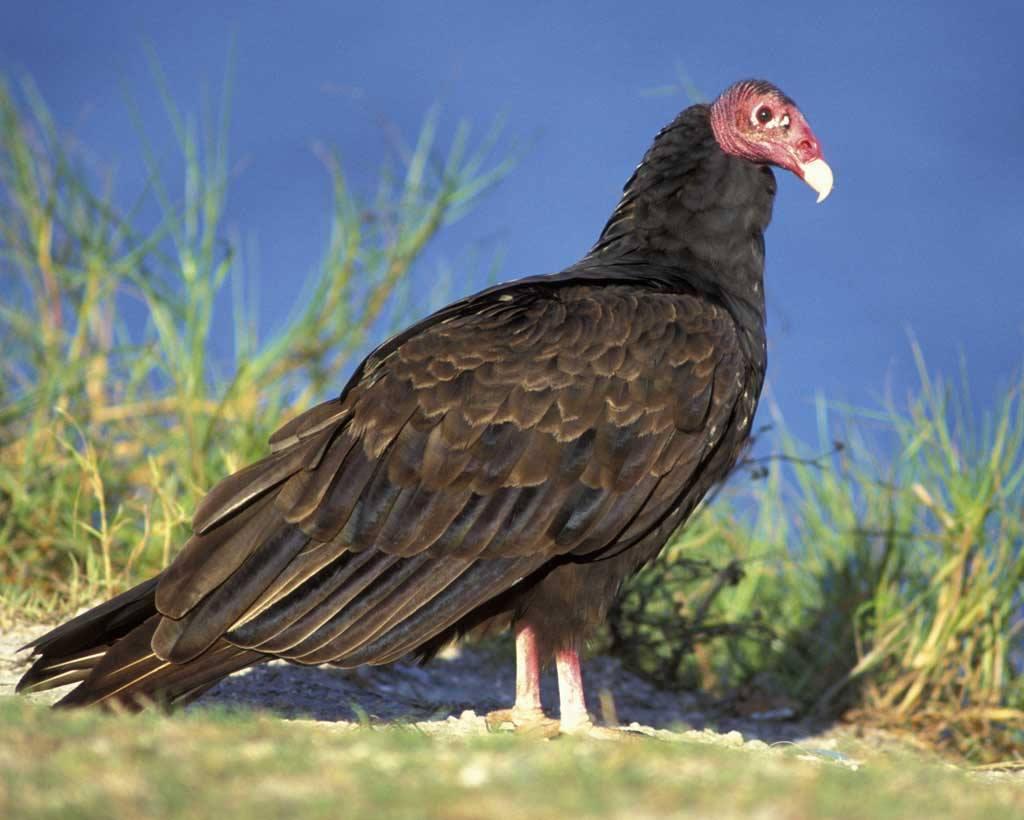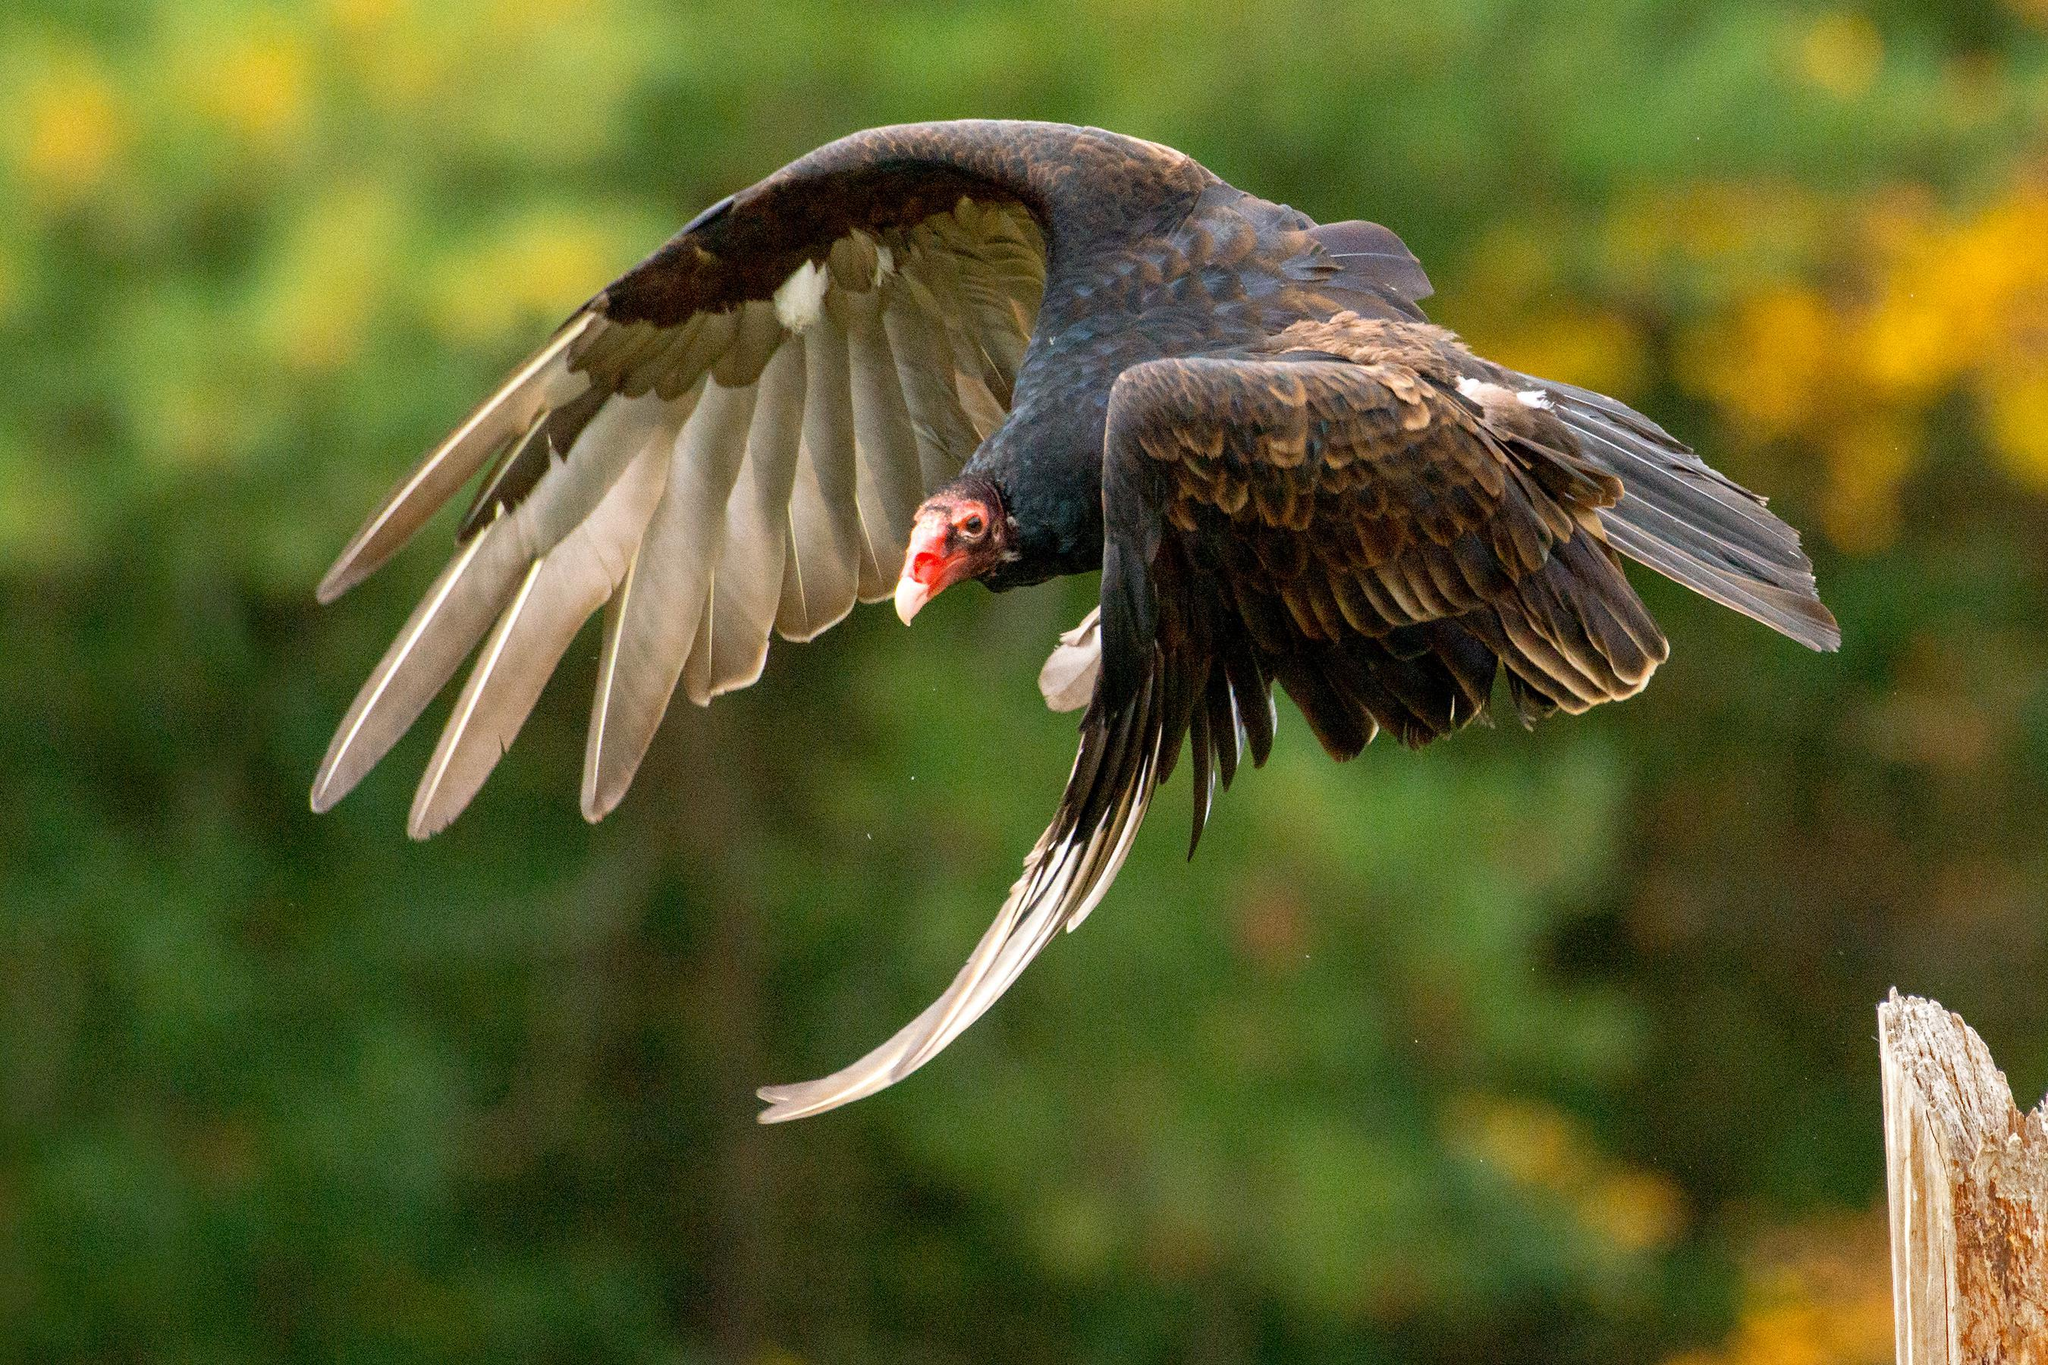The first image is the image on the left, the second image is the image on the right. Analyze the images presented: Is the assertion "The left and right image contains the same number of vultures." valid? Answer yes or no. Yes. The first image is the image on the left, the second image is the image on the right. For the images shown, is this caption "The left image features one vulture with tucked wings, and the right image features one leftward-facing vulture with spread wings." true? Answer yes or no. Yes. 